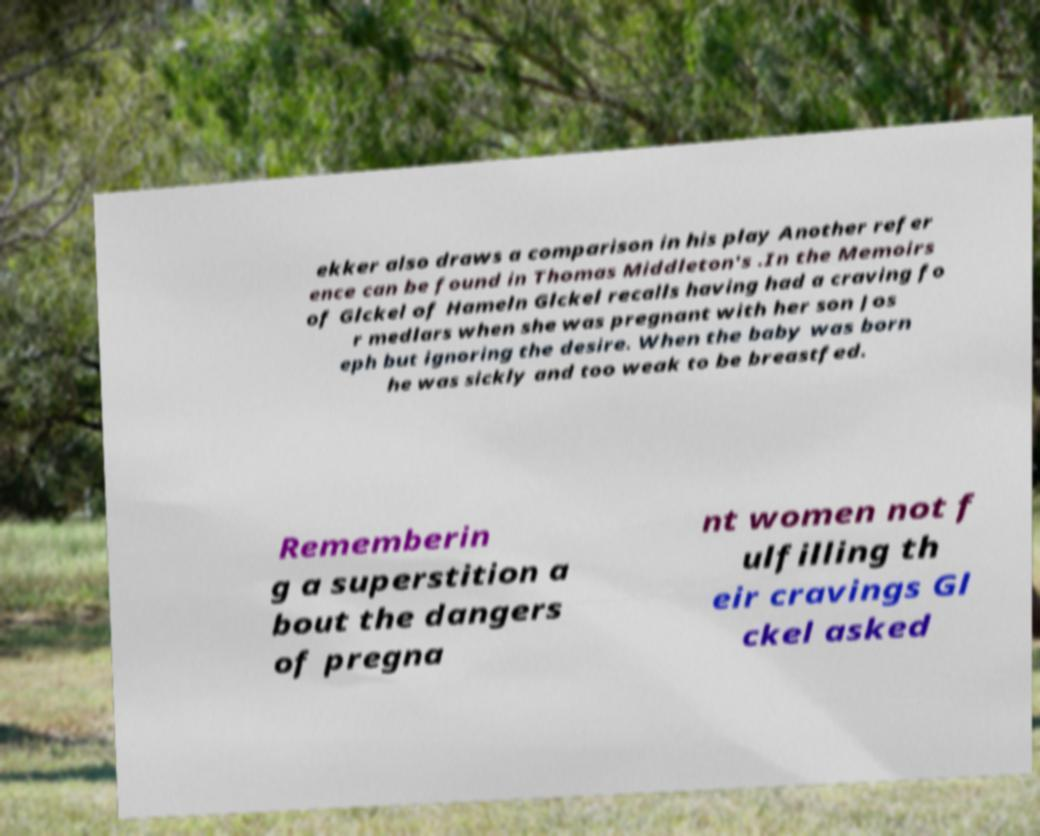Could you extract and type out the text from this image? ekker also draws a comparison in his play Another refer ence can be found in Thomas Middleton's .In the Memoirs of Glckel of Hameln Glckel recalls having had a craving fo r medlars when she was pregnant with her son Jos eph but ignoring the desire. When the baby was born he was sickly and too weak to be breastfed. Rememberin g a superstition a bout the dangers of pregna nt women not f ulfilling th eir cravings Gl ckel asked 